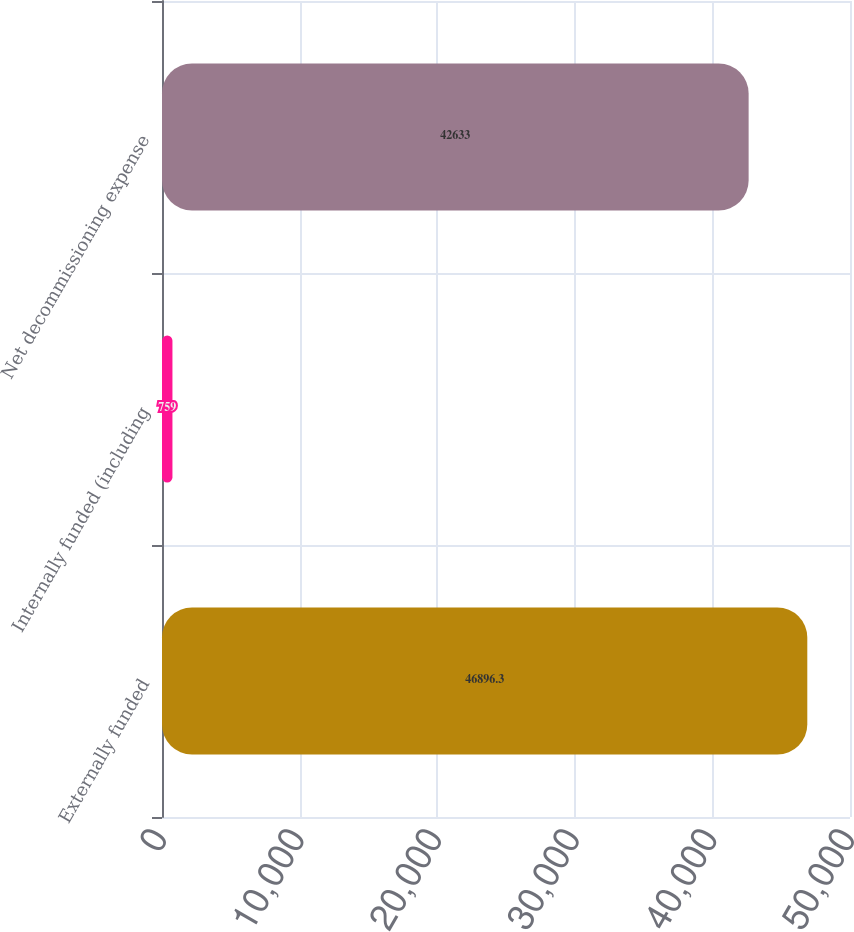Convert chart to OTSL. <chart><loc_0><loc_0><loc_500><loc_500><bar_chart><fcel>Externally funded<fcel>Internally funded (including<fcel>Net decommissioning expense<nl><fcel>46896.3<fcel>759<fcel>42633<nl></chart> 